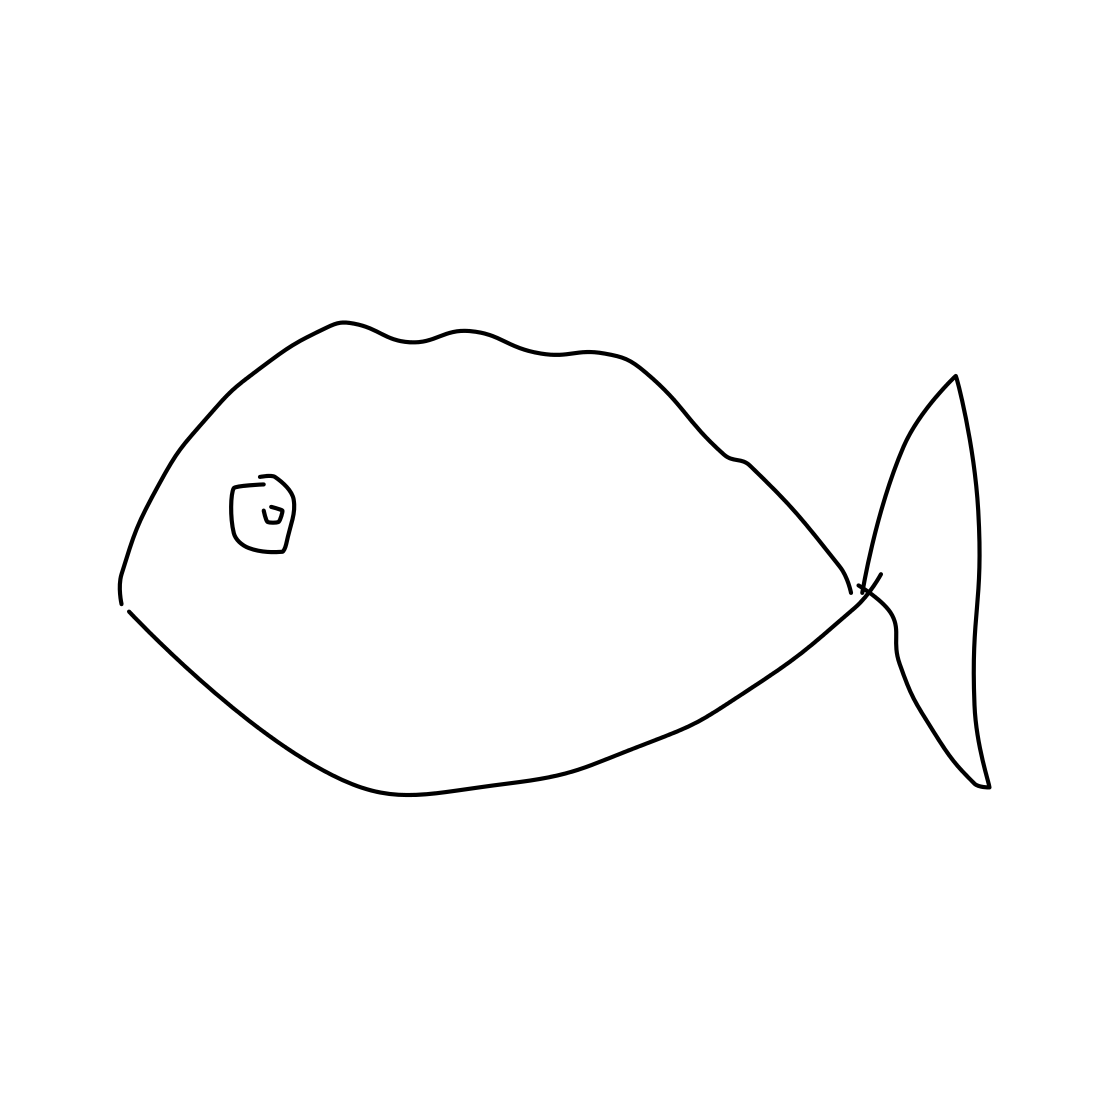Is there a sketchy ant in the picture? There is no ant in the picture. The image shows a simple line drawing of a fish from a side perspective. Its shape and features such as the fin and tail are clearly outlined, with a minimalist style that does not include detailed textures or additional elements like an ant. 